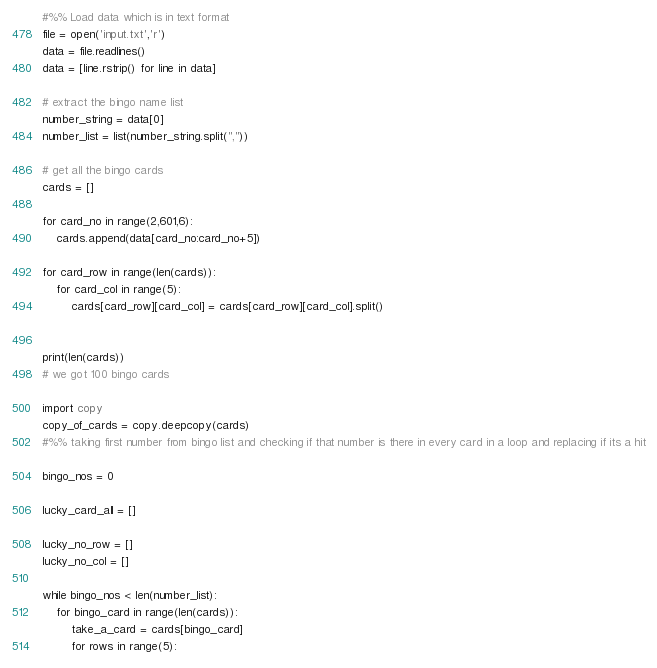<code> <loc_0><loc_0><loc_500><loc_500><_Python_>#%% Load data which is in text format
file = open('input.txt','r')
data = file.readlines()
data = [line.rstrip() for line in data]

# extract the bingo name list
number_string = data[0]
number_list = list(number_string.split(","))

# get all the bingo cards
cards = []

for card_no in range(2,601,6):
    cards.append(data[card_no:card_no+5])

for card_row in range(len(cards)):
    for card_col in range(5):
        cards[card_row][card_col] = cards[card_row][card_col].split()


print(len(cards))
# we got 100 bingo cards

import copy
copy_of_cards = copy.deepcopy(cards)
#%% taking first number from bingo list and checking if that number is there in every card in a loop and replacing if its a hit
  
bingo_nos = 0

lucky_card_all = []

lucky_no_row = []
lucky_no_col = []

while bingo_nos < len(number_list):    
    for bingo_card in range(len(cards)):
        take_a_card = cards[bingo_card]
        for rows in range(5):</code> 